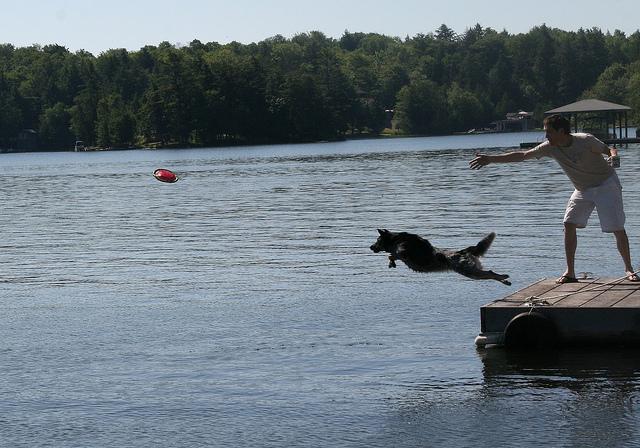Is the dog flying?
Be succinct. No. Is this dog a Corgi?
Quick response, please. No. IS the dog wet?
Short answer required. No. Can this dog swim?
Short answer required. Yes. Will the dog bring back the Frisbee?
Keep it brief. Yes. 